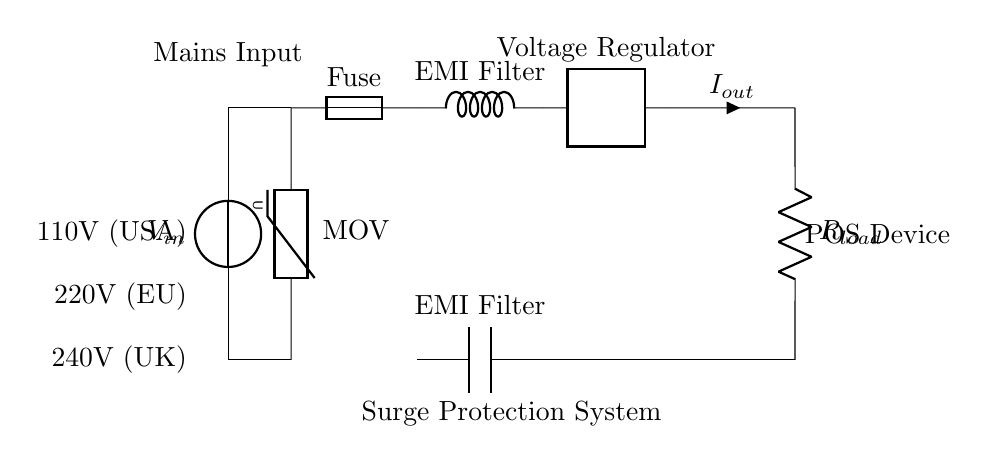What is the main function of the MOV in this circuit? The Metal Oxide Varistor (MOV) is used for transient voltage suppression, meaning it protects the downstream components from voltage spikes. Its placement right after the input indicates its role as the first line of defense against surges.
Answer: transient voltage suppression What does the fuse protect against? The fuse is designed to protect the circuit from overcurrent situations. If the current exceeds a specific threshold, the fuse will blow, breaking the circuit to prevent damage to other components.
Answer: overcurrent What type of device is indicated at the output? The output is connected to a resistor labeled as R load, which typically represents the load that the power source needs to drive, here specified as a Point-of-Sale (POS) device.
Answer: POS device How many different standard voltages are mentioned in the circuit? The circuit indicates three different voltages, which are 110V for the USA, 220V for the EU, and 240V for the UK. This suggests the circuit is adaptable to different regional standards.
Answer: three What role does the voltage regulator play in this circuit? The voltage regulator ensures that the output voltage remains consistent and within a specified range, which is crucial for the stable operation of the connected POS devices regardless of fluctuations in the input voltage.
Answer: maintain consistent output voltage Which component is used to filter electromagnetic interference? The inductor labeled as EMI filter is utilized to reduce electromagnetic interference by impedancing high-frequency noise signals that could impair the performance of the POS devices.
Answer: inductor 